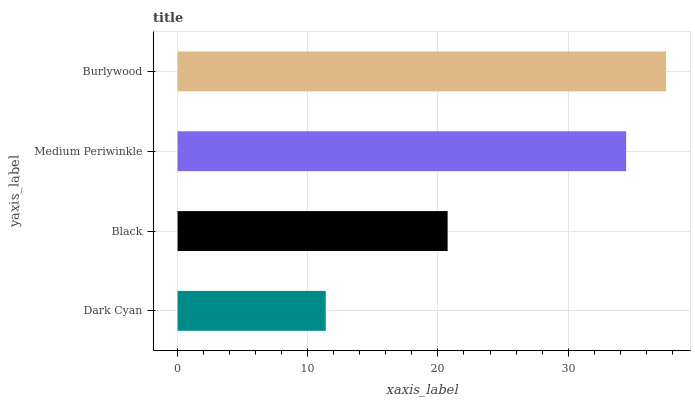Is Dark Cyan the minimum?
Answer yes or no. Yes. Is Burlywood the maximum?
Answer yes or no. Yes. Is Black the minimum?
Answer yes or no. No. Is Black the maximum?
Answer yes or no. No. Is Black greater than Dark Cyan?
Answer yes or no. Yes. Is Dark Cyan less than Black?
Answer yes or no. Yes. Is Dark Cyan greater than Black?
Answer yes or no. No. Is Black less than Dark Cyan?
Answer yes or no. No. Is Medium Periwinkle the high median?
Answer yes or no. Yes. Is Black the low median?
Answer yes or no. Yes. Is Black the high median?
Answer yes or no. No. Is Dark Cyan the low median?
Answer yes or no. No. 